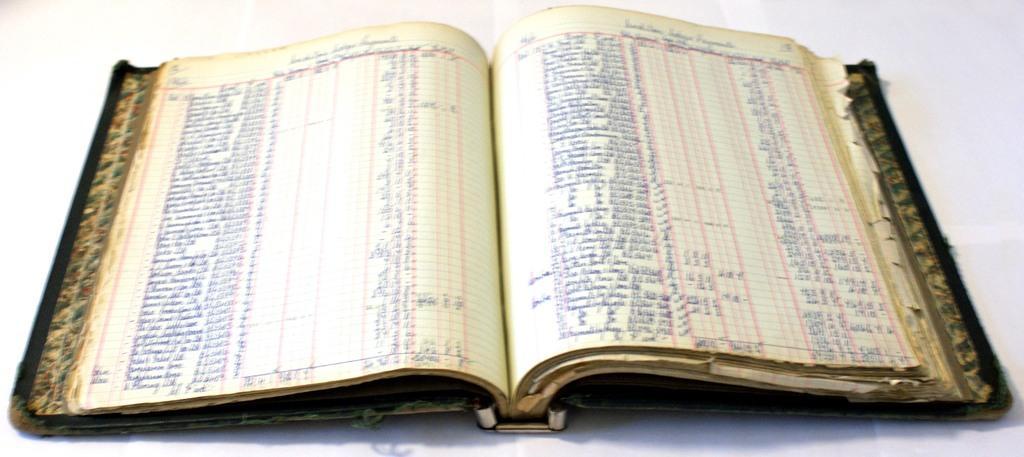Could you give a brief overview of what you see in this image? In the image there is a book, it is opened and there is a lot of text in the book. 